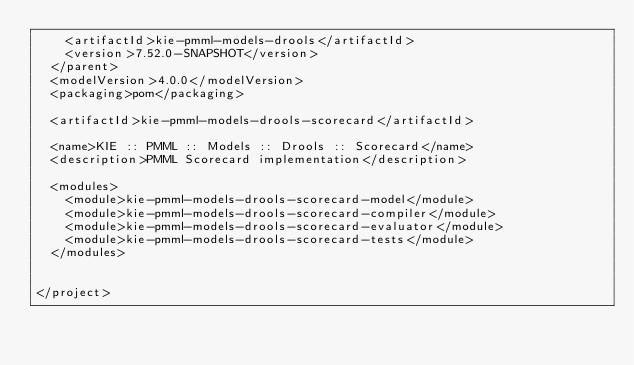Convert code to text. <code><loc_0><loc_0><loc_500><loc_500><_XML_>    <artifactId>kie-pmml-models-drools</artifactId>
    <version>7.52.0-SNAPSHOT</version>
  </parent>
  <modelVersion>4.0.0</modelVersion>
  <packaging>pom</packaging>

  <artifactId>kie-pmml-models-drools-scorecard</artifactId>

  <name>KIE :: PMML :: Models :: Drools :: Scorecard</name>
  <description>PMML Scorecard implementation</description>

  <modules>
    <module>kie-pmml-models-drools-scorecard-model</module>
    <module>kie-pmml-models-drools-scorecard-compiler</module>
    <module>kie-pmml-models-drools-scorecard-evaluator</module>
    <module>kie-pmml-models-drools-scorecard-tests</module>
  </modules>


</project>
</code> 